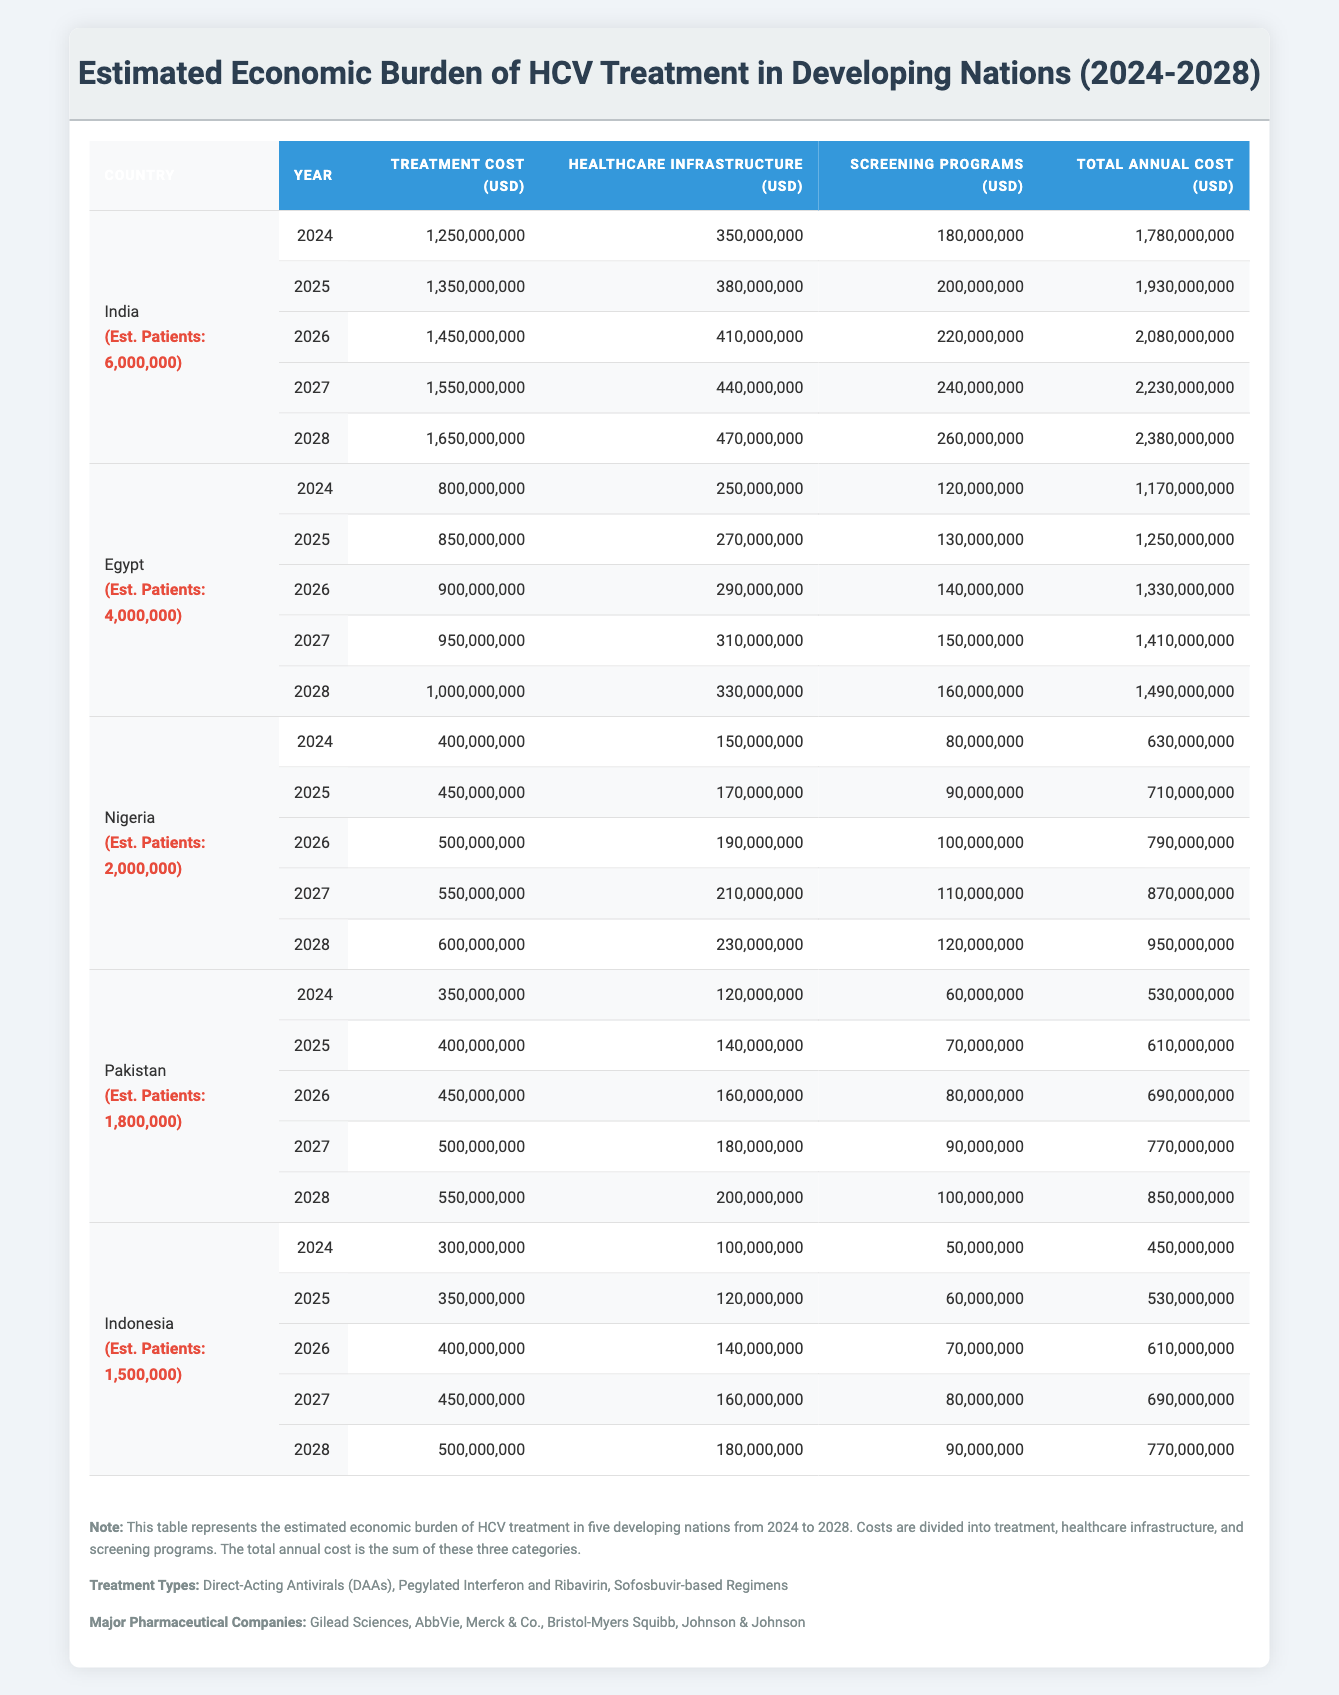What is the total annual cost for HCV treatment in India for 2025? The annual cost in 2025 for India is provided in the table. It lists the treatment cost as 1,350,000,000 USD, healthcare infrastructure cost as 380,000,000 USD, and screening programs as 200,000,000 USD. Summing these gives the total annual cost: 1,350,000,000 + 380,000,000 + 200,000,000 = 1,930,000,000 USD.
Answer: 1,930,000,000 USD What is the trend of treatment costs in Nigeria from 2024 to 2028? The treatment costs for Nigeria over these years are: 400,000,000 (2024), 450,000,000 (2025), 500,000,000 (2026), 550,000,000 (2027), and 600,000,000 (2028). Observing these values indicates an increasing trend, specifically by 50,000,000 each year.
Answer: Increasing What was the highest total annual cost for HCV treatment among the listed countries in 2028? The total annual costs for 2028 are: India at 2,380,000,000 USD, Egypt at 1,490,000,000 USD, Nigeria at 950,000,000 USD, Pakistan at 850,000,000 USD, and Indonesia at 770,000,000 USD. The highest value among these is for India.
Answer: India Is the estimated number of patients in Egypt greater than that in Pakistan? Egypt has an estimated 4,000,000 patients, while Pakistan has 1,800,000. Since 4,000,000 is greater than 1,800,000, the statement is true.
Answer: Yes Calculate the average annual cost for HCV treatment in India from 2024 to 2028. First, we find the total costs for India over the five years: 1,780,000,000 (2024) + 1,930,000,000 (2025) + 2,080,000,000 (2026) + 2,230,000,000 (2027) + 2,380,000,000 (2028) = 10,400,000,000 USD. To find the average, we divide by 5: 10,400,000,000 / 5 = 2,080,000,000 USD.
Answer: 2,080,000,000 USD 